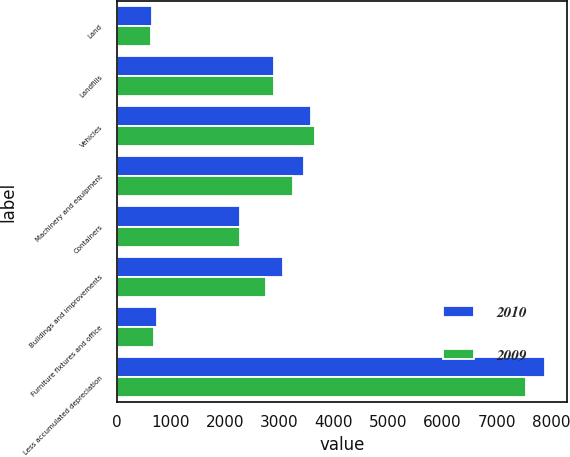Convert chart. <chart><loc_0><loc_0><loc_500><loc_500><stacked_bar_chart><ecel><fcel>Land<fcel>Landfills<fcel>Vehicles<fcel>Machinery and equipment<fcel>Containers<fcel>Buildings and improvements<fcel>Furniture fixtures and office<fcel>Less accumulated depreciation<nl><fcel>2010<fcel>651<fcel>2904.5<fcel>3588<fcel>3454<fcel>2277<fcel>3064<fcel>747<fcel>7898<nl><fcel>2009<fcel>632<fcel>2904.5<fcel>3660<fcel>3251<fcel>2264<fcel>2745<fcel>682<fcel>7546<nl></chart> 